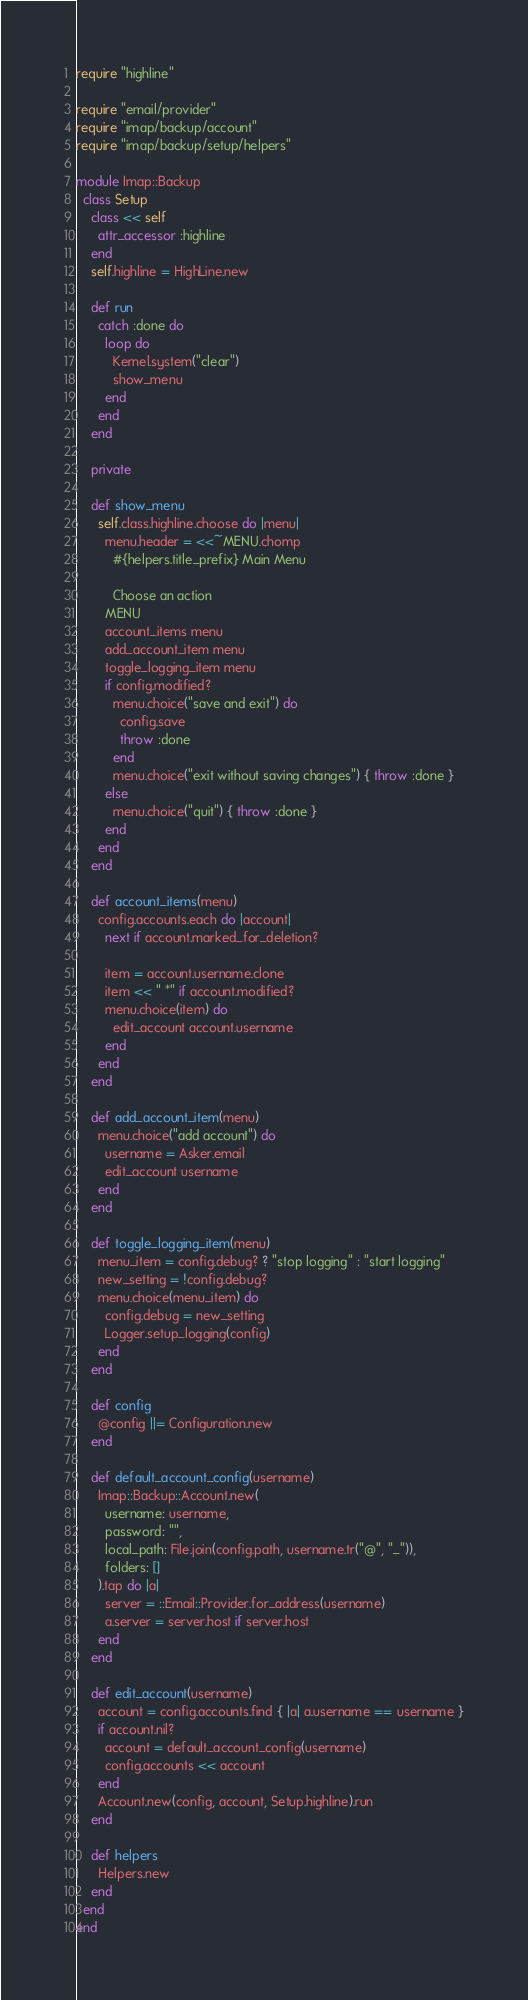<code> <loc_0><loc_0><loc_500><loc_500><_Ruby_>require "highline"

require "email/provider"
require "imap/backup/account"
require "imap/backup/setup/helpers"

module Imap::Backup
  class Setup
    class << self
      attr_accessor :highline
    end
    self.highline = HighLine.new

    def run
      catch :done do
        loop do
          Kernel.system("clear")
          show_menu
        end
      end
    end

    private

    def show_menu
      self.class.highline.choose do |menu|
        menu.header = <<~MENU.chomp
          #{helpers.title_prefix} Main Menu

          Choose an action
        MENU
        account_items menu
        add_account_item menu
        toggle_logging_item menu
        if config.modified?
          menu.choice("save and exit") do
            config.save
            throw :done
          end
          menu.choice("exit without saving changes") { throw :done }
        else
          menu.choice("quit") { throw :done }
        end
      end
    end

    def account_items(menu)
      config.accounts.each do |account|
        next if account.marked_for_deletion?

        item = account.username.clone
        item << " *" if account.modified?
        menu.choice(item) do
          edit_account account.username
        end
      end
    end

    def add_account_item(menu)
      menu.choice("add account") do
        username = Asker.email
        edit_account username
      end
    end

    def toggle_logging_item(menu)
      menu_item = config.debug? ? "stop logging" : "start logging"
      new_setting = !config.debug?
      menu.choice(menu_item) do
        config.debug = new_setting
        Logger.setup_logging(config)
      end
    end

    def config
      @config ||= Configuration.new
    end

    def default_account_config(username)
      Imap::Backup::Account.new(
        username: username,
        password: "",
        local_path: File.join(config.path, username.tr("@", "_")),
        folders: []
      ).tap do |a|
        server = ::Email::Provider.for_address(username)
        a.server = server.host if server.host
      end
    end

    def edit_account(username)
      account = config.accounts.find { |a| a.username == username }
      if account.nil?
        account = default_account_config(username)
        config.accounts << account
      end
      Account.new(config, account, Setup.highline).run
    end

    def helpers
      Helpers.new
    end
  end
end
</code> 